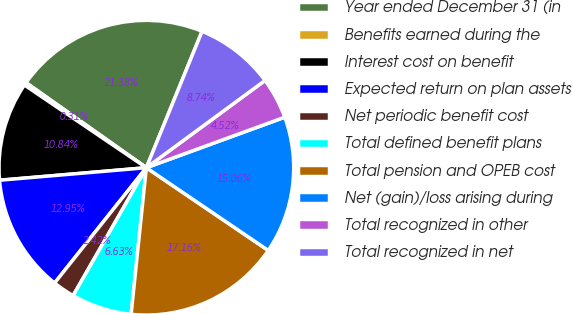<chart> <loc_0><loc_0><loc_500><loc_500><pie_chart><fcel>Year ended December 31 (in<fcel>Benefits earned during the<fcel>Interest cost on benefit<fcel>Expected return on plan assets<fcel>Net periodic benefit cost<fcel>Total defined benefit plans<fcel>Total pension and OPEB cost<fcel>Net (gain)/loss arising during<fcel>Total recognized in other<fcel>Total recognized in net<nl><fcel>21.38%<fcel>0.31%<fcel>10.84%<fcel>12.95%<fcel>2.42%<fcel>6.63%<fcel>17.16%<fcel>15.06%<fcel>4.52%<fcel>8.74%<nl></chart> 